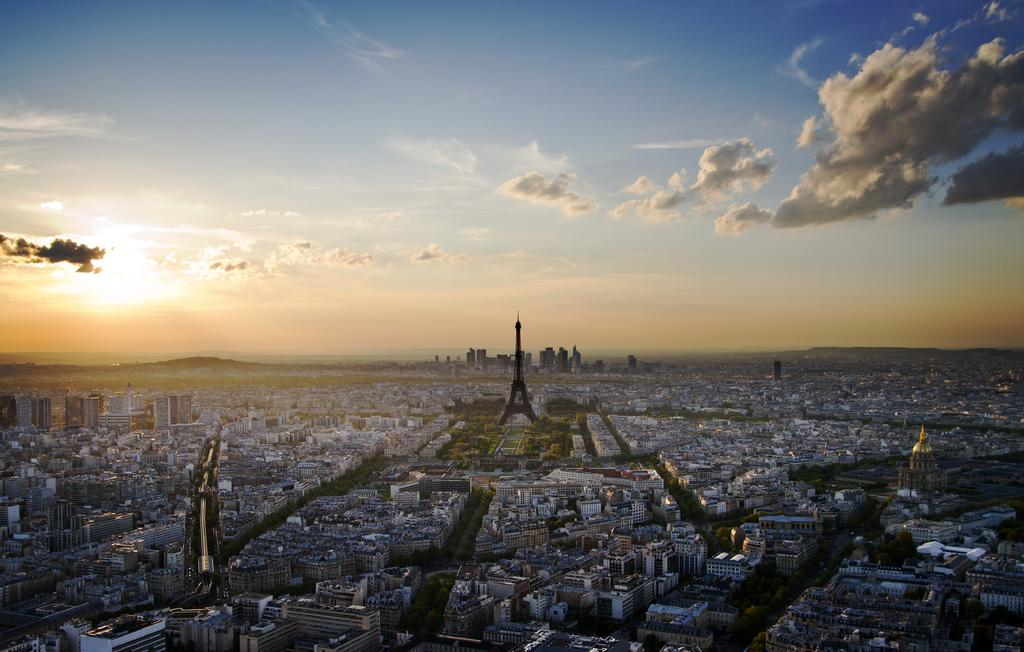What type of view is shown in the image? The image is an aerial view of a city. What structures can be seen in the image? There are buildings and a tower in the image. What natural feature is present in the image? There is a mountain in the image. What celestial body is visible in the image? The sun is visible in the image. What is the condition of the sky in the image? The sky is cloudy in the image. What type of game is being played on the mountain in the image? There is no game being played on the mountain in the image; it is a natural feature. How many pets can be seen in the image? There are no pets visible in the image. 